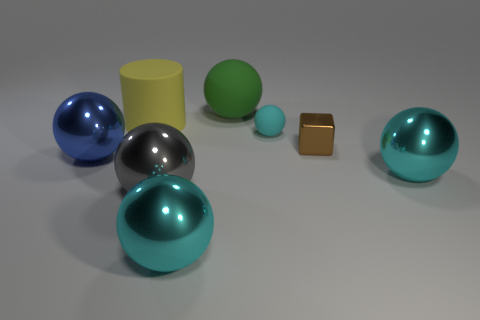Subtract all yellow blocks. How many cyan spheres are left? 3 Subtract all blue balls. How many balls are left? 5 Subtract all gray balls. How many balls are left? 5 Subtract all red balls. Subtract all cyan cubes. How many balls are left? 6 Add 1 rubber things. How many objects exist? 9 Subtract all cylinders. How many objects are left? 7 Add 2 gray balls. How many gray balls are left? 3 Add 4 large rubber objects. How many large rubber objects exist? 6 Subtract 0 purple balls. How many objects are left? 8 Subtract all green spheres. Subtract all gray cylinders. How many objects are left? 7 